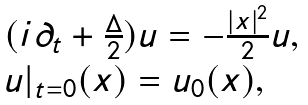<formula> <loc_0><loc_0><loc_500><loc_500>\begin{array} { l l } ( i \partial _ { t } + \frac { \Delta } 2 ) u = - \frac { | x | ^ { 2 } } 2 u , \\ u | _ { t = 0 } ( x ) = u _ { 0 } ( x ) , \end{array}</formula> 